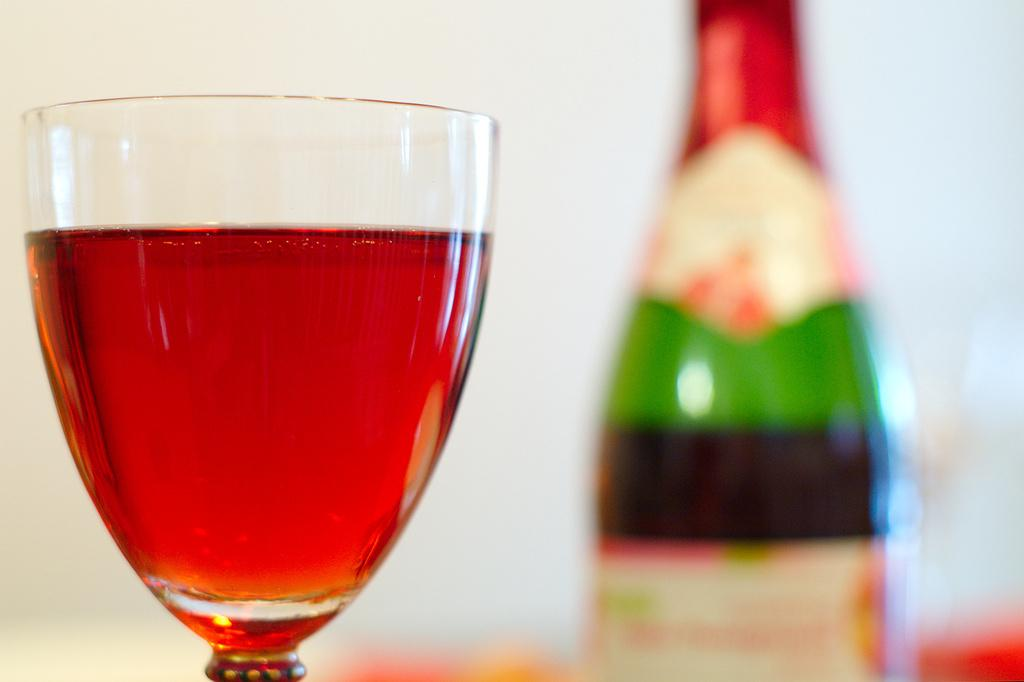What is in the glass that is visible in the image? There is a glass filled with a drink in the image. What else can be seen related to the drink in the image? There is a bottle visible behind the drink in the image. Is there a person using a blade to cut the drink in the image? There is no person or blade present in the image; it only shows a glass filled with a drink and a bottle behind it. 